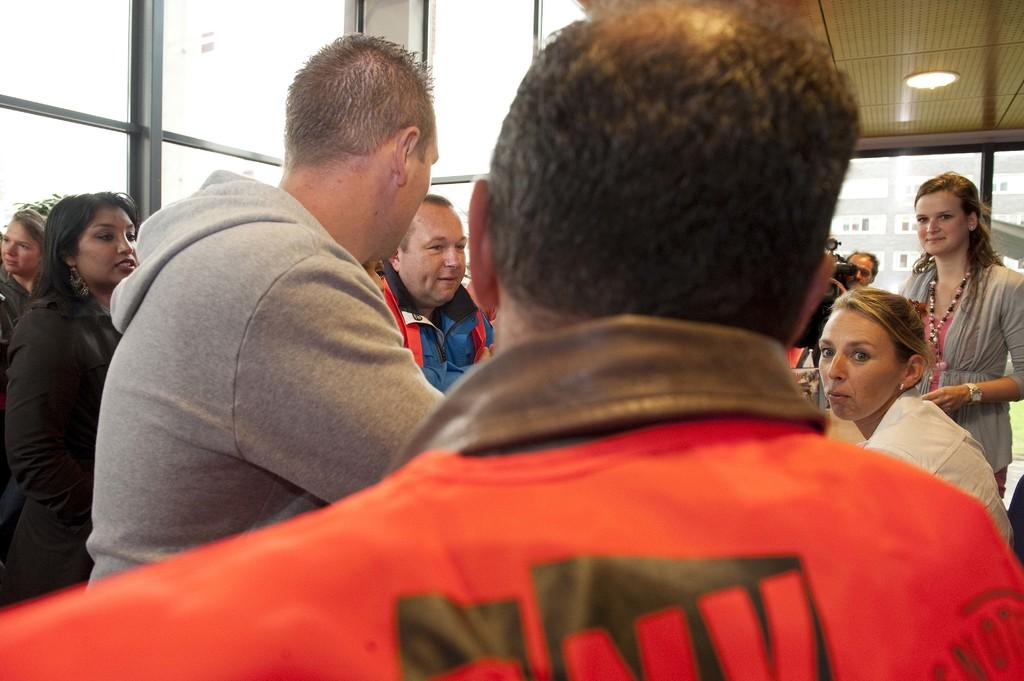How many people are in the room in the image? There are many people in the room in the image. What are some of the people in the room doing? Some people are standing, while others are sitting. What can be seen on the ceiling in the image? There are lights over the ceiling in the image. What is located on the left side of the room in the image? There is a window on the left side of the room in the image. What type of credit can be seen being discussed by the people in the image? There is no credit being discussed in the image; it is a room with people standing and sitting. 